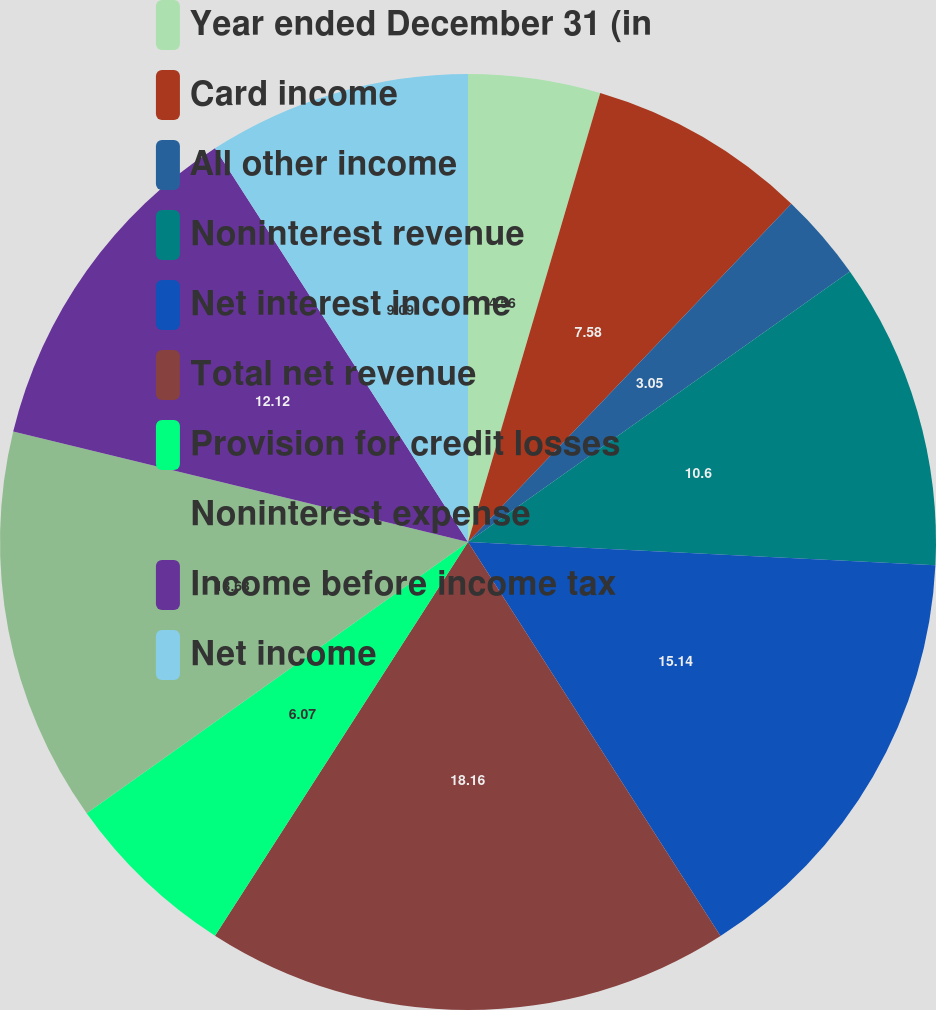<chart> <loc_0><loc_0><loc_500><loc_500><pie_chart><fcel>Year ended December 31 (in<fcel>Card income<fcel>All other income<fcel>Noninterest revenue<fcel>Net interest income<fcel>Total net revenue<fcel>Provision for credit losses<fcel>Noninterest expense<fcel>Income before income tax<fcel>Net income<nl><fcel>4.56%<fcel>7.58%<fcel>3.05%<fcel>10.6%<fcel>15.14%<fcel>18.16%<fcel>6.07%<fcel>13.63%<fcel>12.12%<fcel>9.09%<nl></chart> 